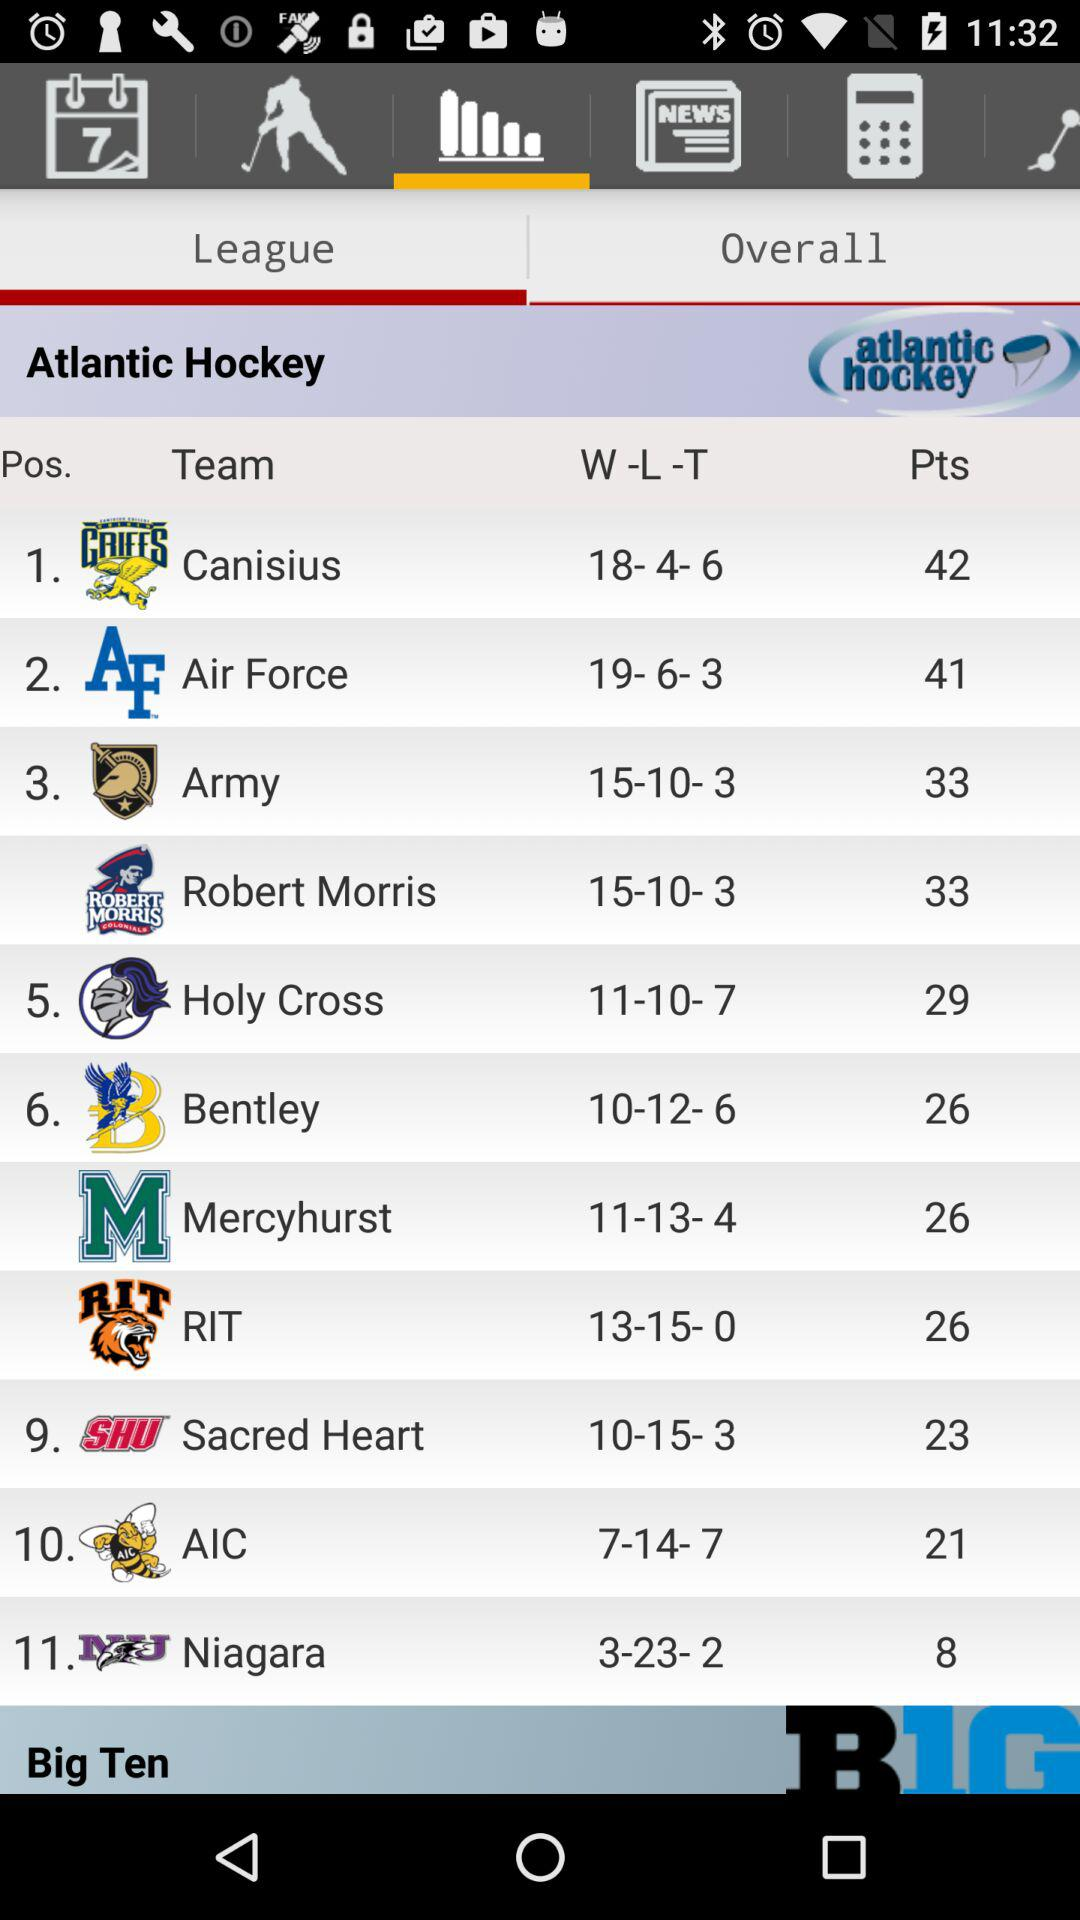How many teams are in the Atlantic Hockey conference?
Answer the question using a single word or phrase. 11 